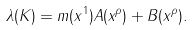Convert formula to latex. <formula><loc_0><loc_0><loc_500><loc_500>\lambda ( { K } ) = m ( x ^ { 1 } ) A ( x ^ { \rho } ) + B ( x ^ { \rho } ) .</formula> 